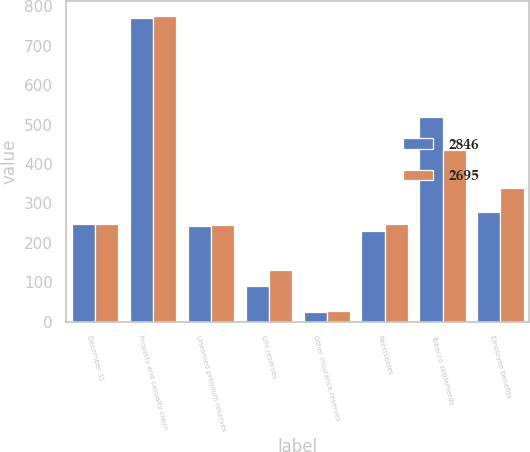<chart> <loc_0><loc_0><loc_500><loc_500><stacked_bar_chart><ecel><fcel>December 31<fcel>Property and casualty claim<fcel>Unearned premium reserves<fcel>Life reserves<fcel>Other insurance reserves<fcel>Receivables<fcel>Tobacco settlements<fcel>Employee benefits<nl><fcel>2846<fcel>246.5<fcel>771<fcel>243<fcel>89<fcel>24<fcel>231<fcel>520<fcel>277<nl><fcel>2695<fcel>246.5<fcel>775<fcel>245<fcel>132<fcel>26<fcel>248<fcel>436<fcel>339<nl></chart> 